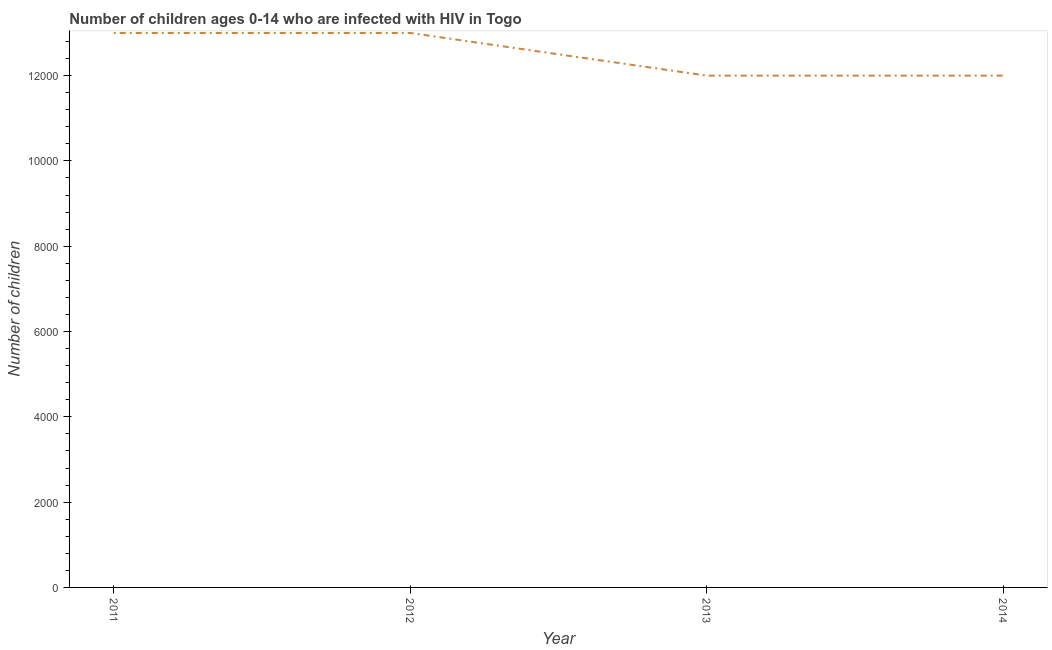What is the number of children living with hiv in 2012?
Offer a very short reply. 1.30e+04. Across all years, what is the maximum number of children living with hiv?
Ensure brevity in your answer.  1.30e+04. Across all years, what is the minimum number of children living with hiv?
Your answer should be compact. 1.20e+04. What is the sum of the number of children living with hiv?
Offer a terse response. 5.00e+04. What is the difference between the number of children living with hiv in 2013 and 2014?
Your answer should be compact. 0. What is the average number of children living with hiv per year?
Provide a succinct answer. 1.25e+04. What is the median number of children living with hiv?
Your response must be concise. 1.25e+04. In how many years, is the number of children living with hiv greater than 8400 ?
Offer a very short reply. 4. Do a majority of the years between 2012 and 2014 (inclusive) have number of children living with hiv greater than 400 ?
Provide a short and direct response. Yes. What is the ratio of the number of children living with hiv in 2011 to that in 2012?
Your answer should be compact. 1. Is the number of children living with hiv in 2012 less than that in 2013?
Ensure brevity in your answer.  No. Is the difference between the number of children living with hiv in 2012 and 2014 greater than the difference between any two years?
Your answer should be compact. Yes. Is the sum of the number of children living with hiv in 2013 and 2014 greater than the maximum number of children living with hiv across all years?
Your answer should be compact. Yes. What is the difference between the highest and the lowest number of children living with hiv?
Ensure brevity in your answer.  1000. In how many years, is the number of children living with hiv greater than the average number of children living with hiv taken over all years?
Make the answer very short. 2. Does the number of children living with hiv monotonically increase over the years?
Ensure brevity in your answer.  No. How many years are there in the graph?
Keep it short and to the point. 4. What is the title of the graph?
Your answer should be compact. Number of children ages 0-14 who are infected with HIV in Togo. What is the label or title of the X-axis?
Make the answer very short. Year. What is the label or title of the Y-axis?
Offer a terse response. Number of children. What is the Number of children in 2011?
Offer a terse response. 1.30e+04. What is the Number of children in 2012?
Offer a terse response. 1.30e+04. What is the Number of children of 2013?
Provide a succinct answer. 1.20e+04. What is the Number of children of 2014?
Keep it short and to the point. 1.20e+04. What is the difference between the Number of children in 2011 and 2013?
Your answer should be very brief. 1000. What is the ratio of the Number of children in 2011 to that in 2013?
Offer a terse response. 1.08. What is the ratio of the Number of children in 2011 to that in 2014?
Make the answer very short. 1.08. What is the ratio of the Number of children in 2012 to that in 2013?
Keep it short and to the point. 1.08. What is the ratio of the Number of children in 2012 to that in 2014?
Provide a succinct answer. 1.08. 